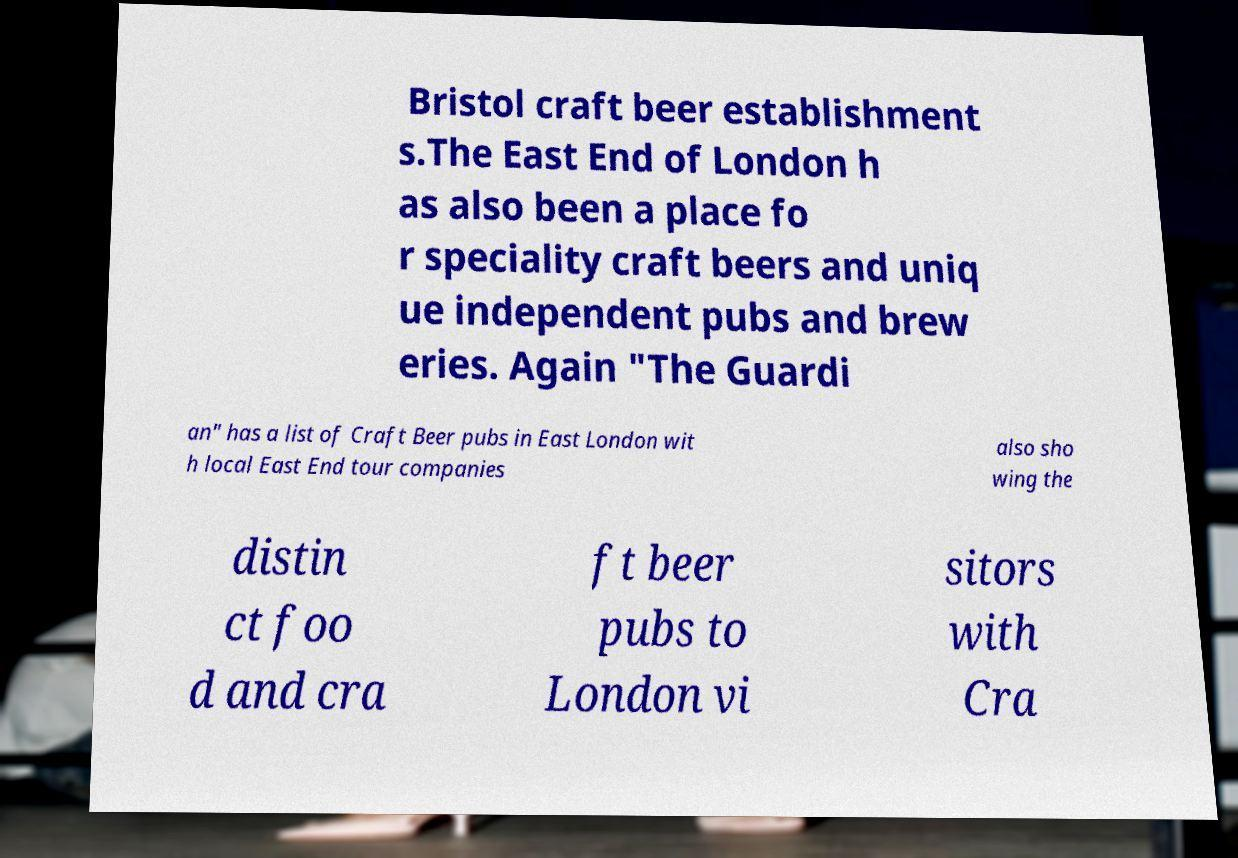I need the written content from this picture converted into text. Can you do that? Bristol craft beer establishment s.The East End of London h as also been a place fo r speciality craft beers and uniq ue independent pubs and brew eries. Again "The Guardi an" has a list of Craft Beer pubs in East London wit h local East End tour companies also sho wing the distin ct foo d and cra ft beer pubs to London vi sitors with Cra 